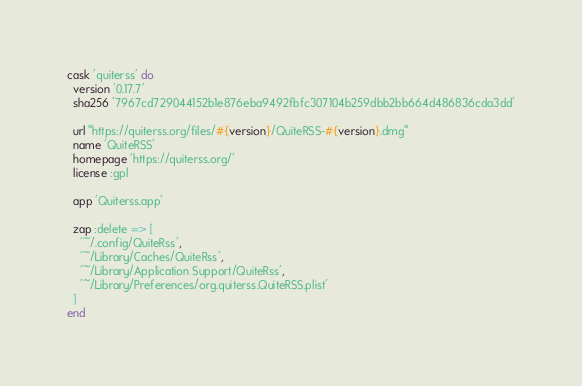<code> <loc_0><loc_0><loc_500><loc_500><_Ruby_>cask 'quiterss' do
  version '0.17.7'
  sha256 '7967cd729044152b1e876eba9492fbfc307104b259dbb2bb664d486836cda3dd'

  url "https://quiterss.org/files/#{version}/QuiteRSS-#{version}.dmg"
  name 'QuiteRSS'
  homepage 'https://quiterss.org/'
  license :gpl

  app 'Quiterss.app'

  zap :delete => [
    '~/.config/QuiteRss',
    '~/Library/Caches/QuiteRss',
    '~/Library/Application Support/QuiteRss',
    '~/Library/Preferences/org.quiterss.QuiteRSS.plist'
  ]
end
</code> 